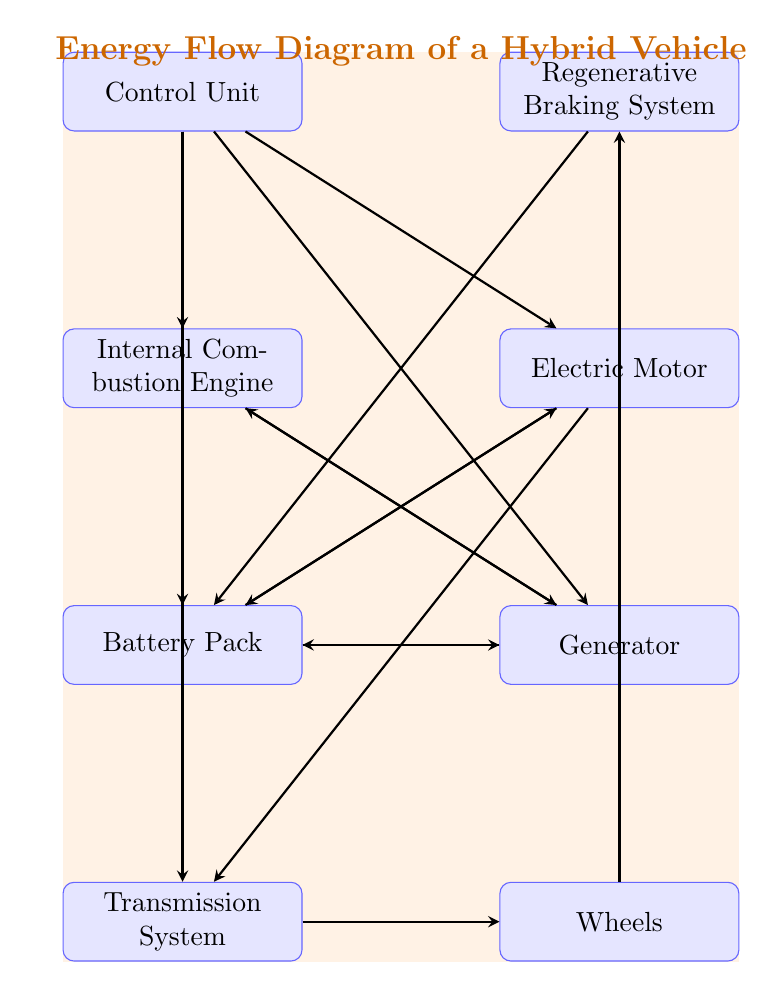What is the first node in the diagram? The diagram shows the flow starting from the 'Control Unit' at the top, but the first component involved in energy flow is the 'Internal Combustion Engine' directly affecting the transmission.
Answer: Internal Combustion Engine How many components are in the diagram? Counting all the distinct components displayed, we find a total of eight nodes in the diagram: Control Unit, Internal Combustion Engine, Electric Motor, Battery Pack, Generator, Transmission System, Wheels, and Regenerative Braking System.
Answer: Eight Which nodes are connected to the battery? The diagram indicates direct connections from both the 'Electric Motor' and 'Generator' to the 'Battery Pack', along with feedback from the 'Regenerative Braking System', showing energy flow into the battery.
Answer: Electric Motor and Generator What does the 'Control Unit' influence? The 'Control Unit' is shown with arrows leading to the 'Internal Combustion Engine', 'Electric Motor', 'Battery Pack', and 'Generator', indicating that it influences all these components for coordinated operation.
Answer: Internal Combustion Engine, Electric Motor, Battery Pack, Generator Which component is connected to the 'Wheels'? In the diagram, the energy flows directly from the 'Transmission System' to the 'Wheels', demonstrating how power is transmitted for vehicle movement.
Answer: Transmission System 